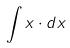Convert formula to latex. <formula><loc_0><loc_0><loc_500><loc_500>\int x \cdot d x</formula> 